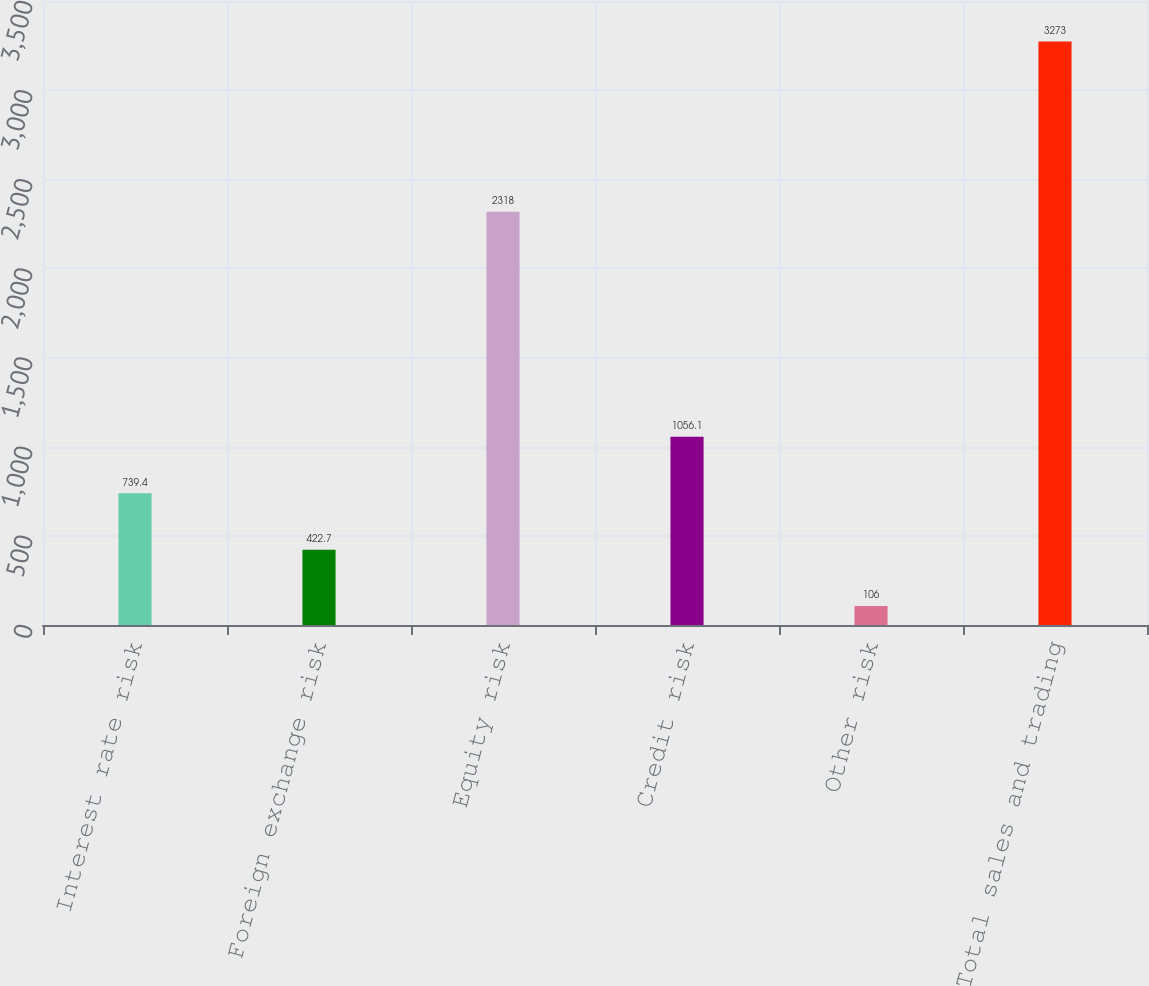<chart> <loc_0><loc_0><loc_500><loc_500><bar_chart><fcel>Interest rate risk<fcel>Foreign exchange risk<fcel>Equity risk<fcel>Credit risk<fcel>Other risk<fcel>Total sales and trading<nl><fcel>739.4<fcel>422.7<fcel>2318<fcel>1056.1<fcel>106<fcel>3273<nl></chart> 